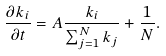<formula> <loc_0><loc_0><loc_500><loc_500>\frac { \partial k _ { i } } { \partial t } = A \frac { k _ { i } } { \sum _ { j = 1 } ^ { N } k _ { j } } + \frac { 1 } { N } .</formula> 